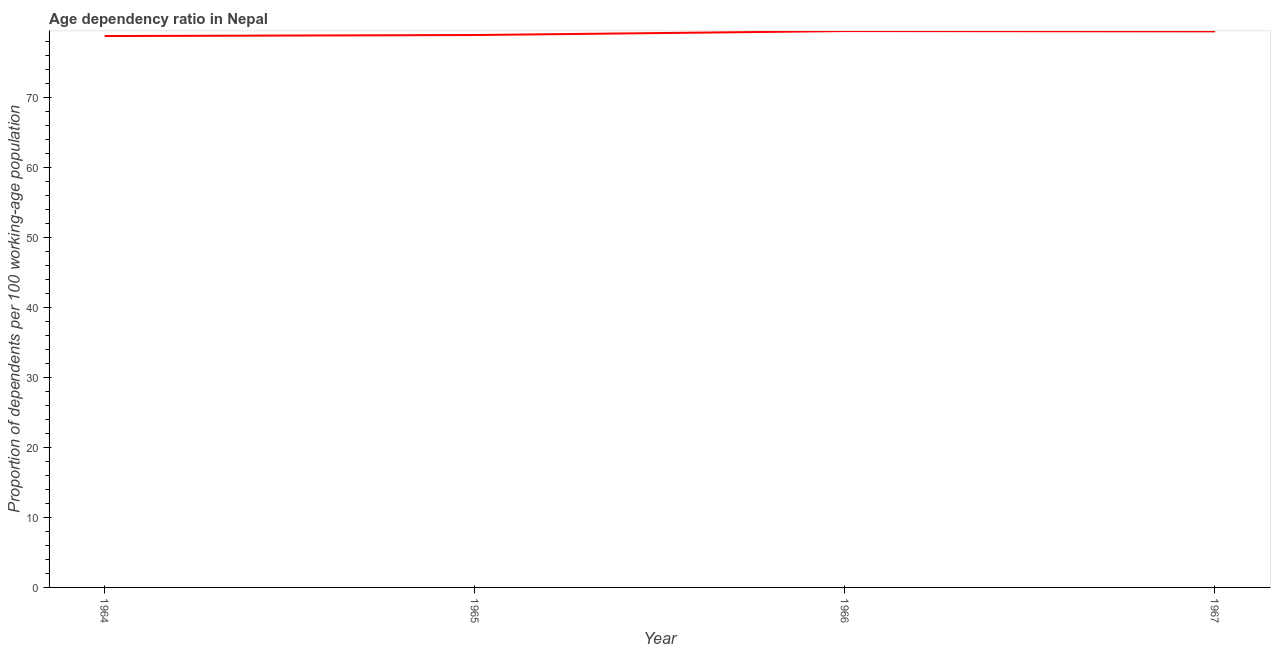What is the age dependency ratio in 1965?
Your answer should be compact. 78.93. Across all years, what is the maximum age dependency ratio?
Ensure brevity in your answer.  79.5. Across all years, what is the minimum age dependency ratio?
Your answer should be very brief. 78.79. In which year was the age dependency ratio maximum?
Your answer should be compact. 1966. In which year was the age dependency ratio minimum?
Give a very brief answer. 1964. What is the sum of the age dependency ratio?
Provide a succinct answer. 316.67. What is the difference between the age dependency ratio in 1965 and 1967?
Your answer should be compact. -0.52. What is the average age dependency ratio per year?
Offer a terse response. 79.17. What is the median age dependency ratio?
Give a very brief answer. 79.19. Do a majority of the years between 1967 and 1966 (inclusive) have age dependency ratio greater than 74 ?
Your answer should be compact. No. What is the ratio of the age dependency ratio in 1964 to that in 1967?
Give a very brief answer. 0.99. Is the age dependency ratio in 1966 less than that in 1967?
Your answer should be very brief. No. What is the difference between the highest and the second highest age dependency ratio?
Your response must be concise. 0.04. Is the sum of the age dependency ratio in 1964 and 1966 greater than the maximum age dependency ratio across all years?
Offer a terse response. Yes. What is the difference between the highest and the lowest age dependency ratio?
Your response must be concise. 0.71. In how many years, is the age dependency ratio greater than the average age dependency ratio taken over all years?
Your answer should be very brief. 2. Does the age dependency ratio monotonically increase over the years?
Give a very brief answer. No. How many years are there in the graph?
Offer a very short reply. 4. Does the graph contain any zero values?
Make the answer very short. No. Does the graph contain grids?
Your response must be concise. No. What is the title of the graph?
Provide a succinct answer. Age dependency ratio in Nepal. What is the label or title of the Y-axis?
Keep it short and to the point. Proportion of dependents per 100 working-age population. What is the Proportion of dependents per 100 working-age population in 1964?
Provide a short and direct response. 78.79. What is the Proportion of dependents per 100 working-age population of 1965?
Your answer should be very brief. 78.93. What is the Proportion of dependents per 100 working-age population in 1966?
Your response must be concise. 79.5. What is the Proportion of dependents per 100 working-age population in 1967?
Your answer should be compact. 79.46. What is the difference between the Proportion of dependents per 100 working-age population in 1964 and 1965?
Ensure brevity in your answer.  -0.14. What is the difference between the Proportion of dependents per 100 working-age population in 1964 and 1966?
Provide a succinct answer. -0.71. What is the difference between the Proportion of dependents per 100 working-age population in 1964 and 1967?
Your response must be concise. -0.67. What is the difference between the Proportion of dependents per 100 working-age population in 1965 and 1966?
Ensure brevity in your answer.  -0.57. What is the difference between the Proportion of dependents per 100 working-age population in 1965 and 1967?
Make the answer very short. -0.52. What is the difference between the Proportion of dependents per 100 working-age population in 1966 and 1967?
Your response must be concise. 0.04. What is the ratio of the Proportion of dependents per 100 working-age population in 1964 to that in 1965?
Give a very brief answer. 1. What is the ratio of the Proportion of dependents per 100 working-age population in 1964 to that in 1967?
Offer a terse response. 0.99. What is the ratio of the Proportion of dependents per 100 working-age population in 1965 to that in 1966?
Your answer should be very brief. 0.99. What is the ratio of the Proportion of dependents per 100 working-age population in 1965 to that in 1967?
Make the answer very short. 0.99. What is the ratio of the Proportion of dependents per 100 working-age population in 1966 to that in 1967?
Provide a succinct answer. 1. 